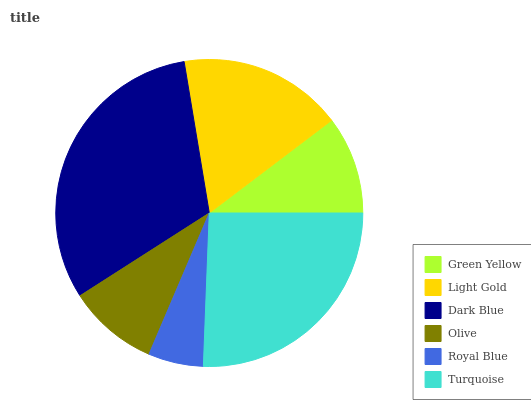Is Royal Blue the minimum?
Answer yes or no. Yes. Is Dark Blue the maximum?
Answer yes or no. Yes. Is Light Gold the minimum?
Answer yes or no. No. Is Light Gold the maximum?
Answer yes or no. No. Is Light Gold greater than Green Yellow?
Answer yes or no. Yes. Is Green Yellow less than Light Gold?
Answer yes or no. Yes. Is Green Yellow greater than Light Gold?
Answer yes or no. No. Is Light Gold less than Green Yellow?
Answer yes or no. No. Is Light Gold the high median?
Answer yes or no. Yes. Is Green Yellow the low median?
Answer yes or no. Yes. Is Turquoise the high median?
Answer yes or no. No. Is Dark Blue the low median?
Answer yes or no. No. 